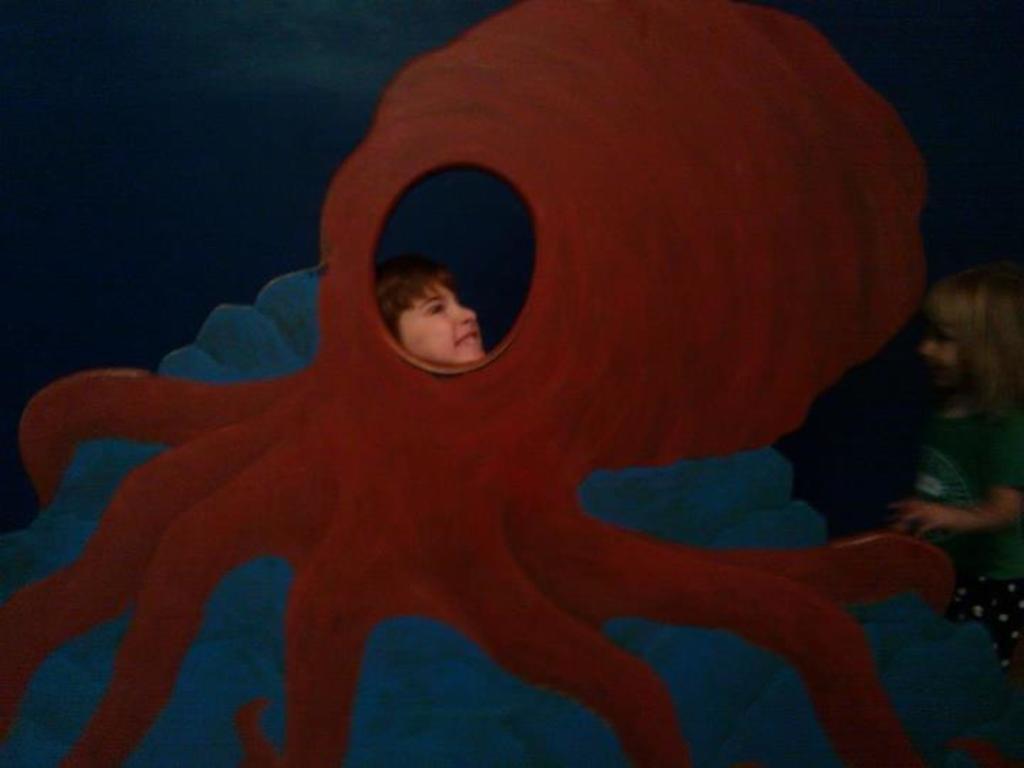Please provide a concise description of this image. In this picture we can see a frame and there are two children. 